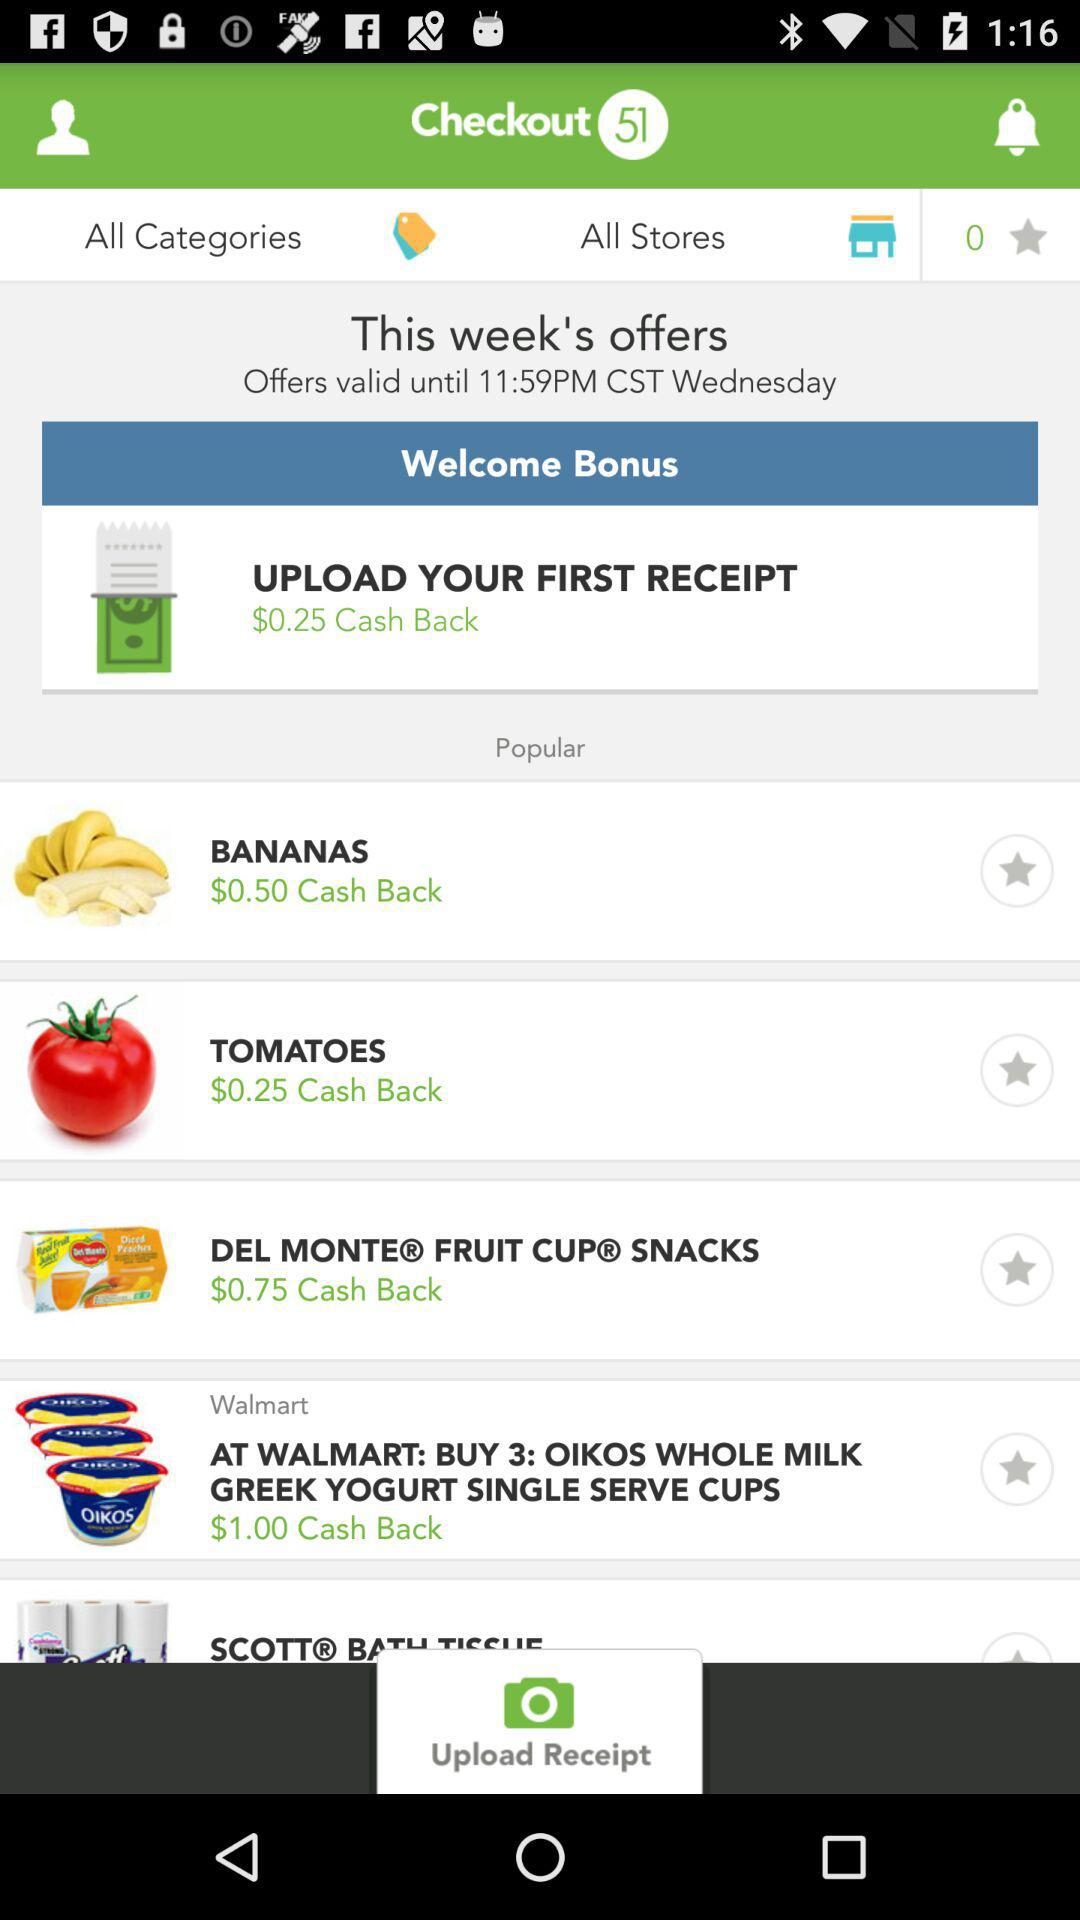Until what day are the offers valid? The offers are valid until Wednesday. 